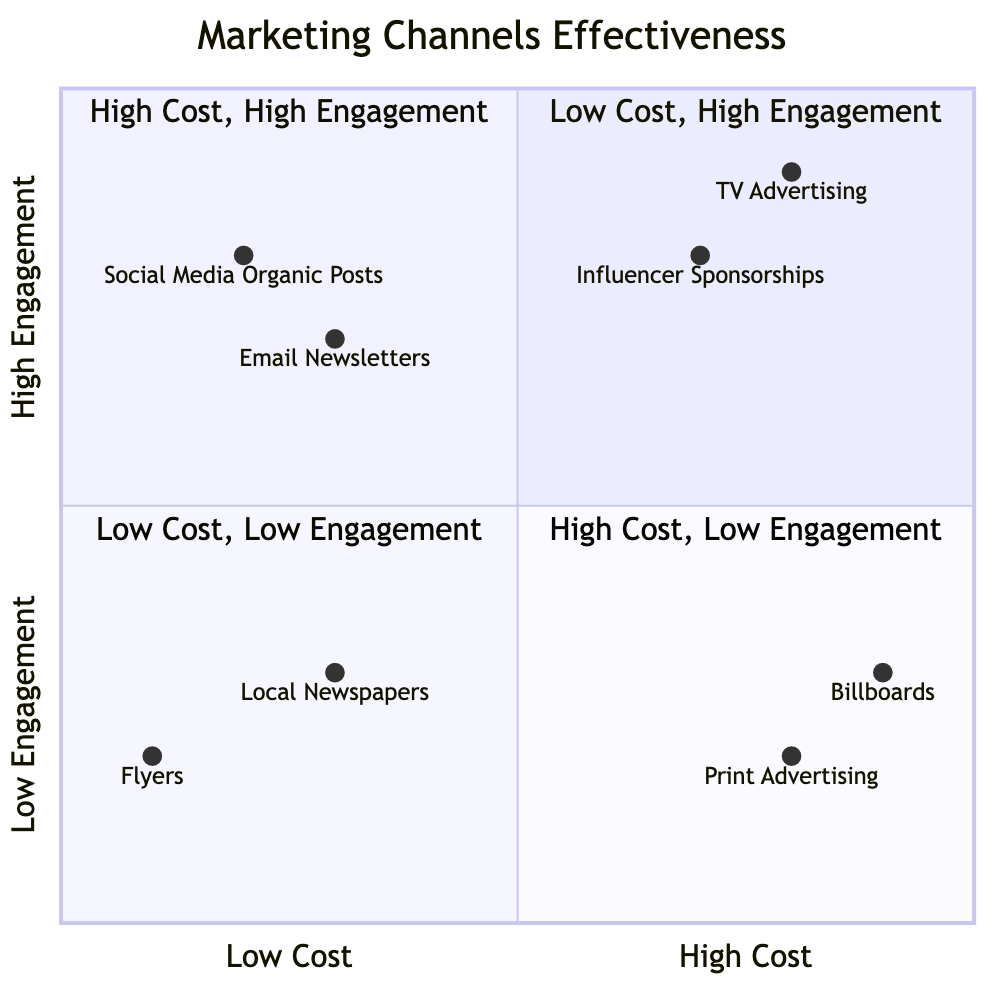What marketing channels fall into the High Cost and High Engagement quadrant? In the diagram, the High Cost and High Engagement quadrant includes two nodes: TV Advertising and Influencer Sponsorships. They are placed in this quadrant because they have high production costs while also achieving high user engagement.
Answer: TV Advertising, Influencer Sponsorships Which marketing channel has the lowest engagement? Examining the diagram, the marketing channel with the lowest engagement is Print Advertising, which is positioned in the High Cost and Low Engagement quadrant. This is due to its design and placement costs, often leading to passive engagement from viewers.
Answer: Print Advertising How many marketing channels are listed in the Low Cost and Low Engagement quadrant? By observing the diagram, there are two marketing channels placed in the Low Cost and Low Engagement quadrant: Flyers and Local Newspapers. This information can be counted directly from the nodes in that quadrant.
Answer: 2 Which channel has a higher cost: Social Media Organic Posts or Email Newsletters? In the diagram, Social Media Organic Posts is in the Low Cost and High Engagement quadrant, while Email Newsletters is also in the same Low Cost and High Engagement quadrant. Since both are placed in the Low Cost quadrant, they do not have a cost hierarchy between them relative to one another.
Answer: Neither What is the engagement level of Billboards? The diagram shows Billboards positioned in the High Cost and Low Engagement quadrant, where its engagement level is indicated as 0.3. This placement is based on the costs associated with renting and installing billboards while also noting the limited engagement opportunities.
Answer: 0.3 